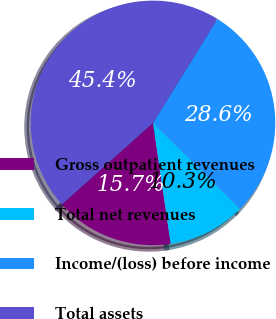Convert chart. <chart><loc_0><loc_0><loc_500><loc_500><pie_chart><fcel>Gross outpatient revenues<fcel>Total net revenues<fcel>Income/(loss) before income<fcel>Total assets<nl><fcel>15.7%<fcel>10.3%<fcel>28.56%<fcel>45.44%<nl></chart> 